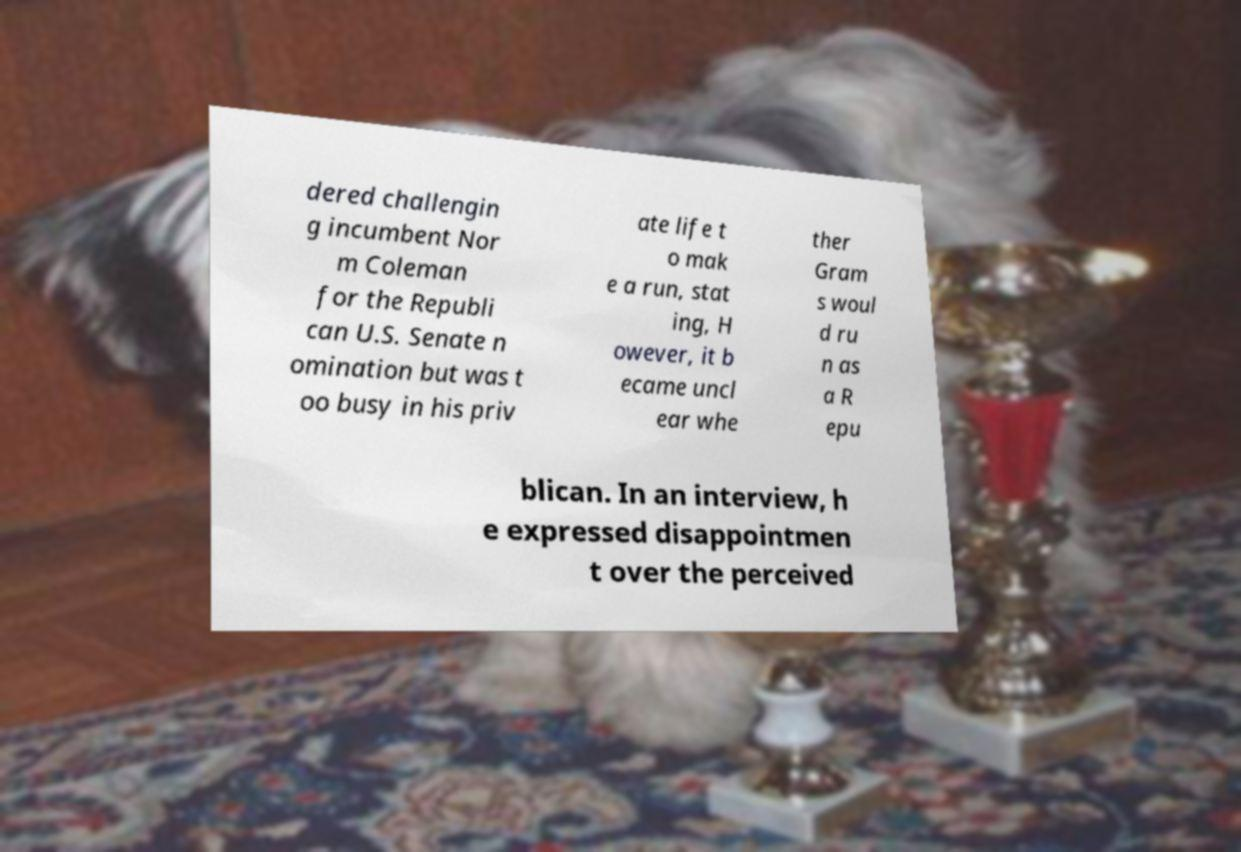Can you read and provide the text displayed in the image?This photo seems to have some interesting text. Can you extract and type it out for me? dered challengin g incumbent Nor m Coleman for the Republi can U.S. Senate n omination but was t oo busy in his priv ate life t o mak e a run, stat ing, H owever, it b ecame uncl ear whe ther Gram s woul d ru n as a R epu blican. In an interview, h e expressed disappointmen t over the perceived 